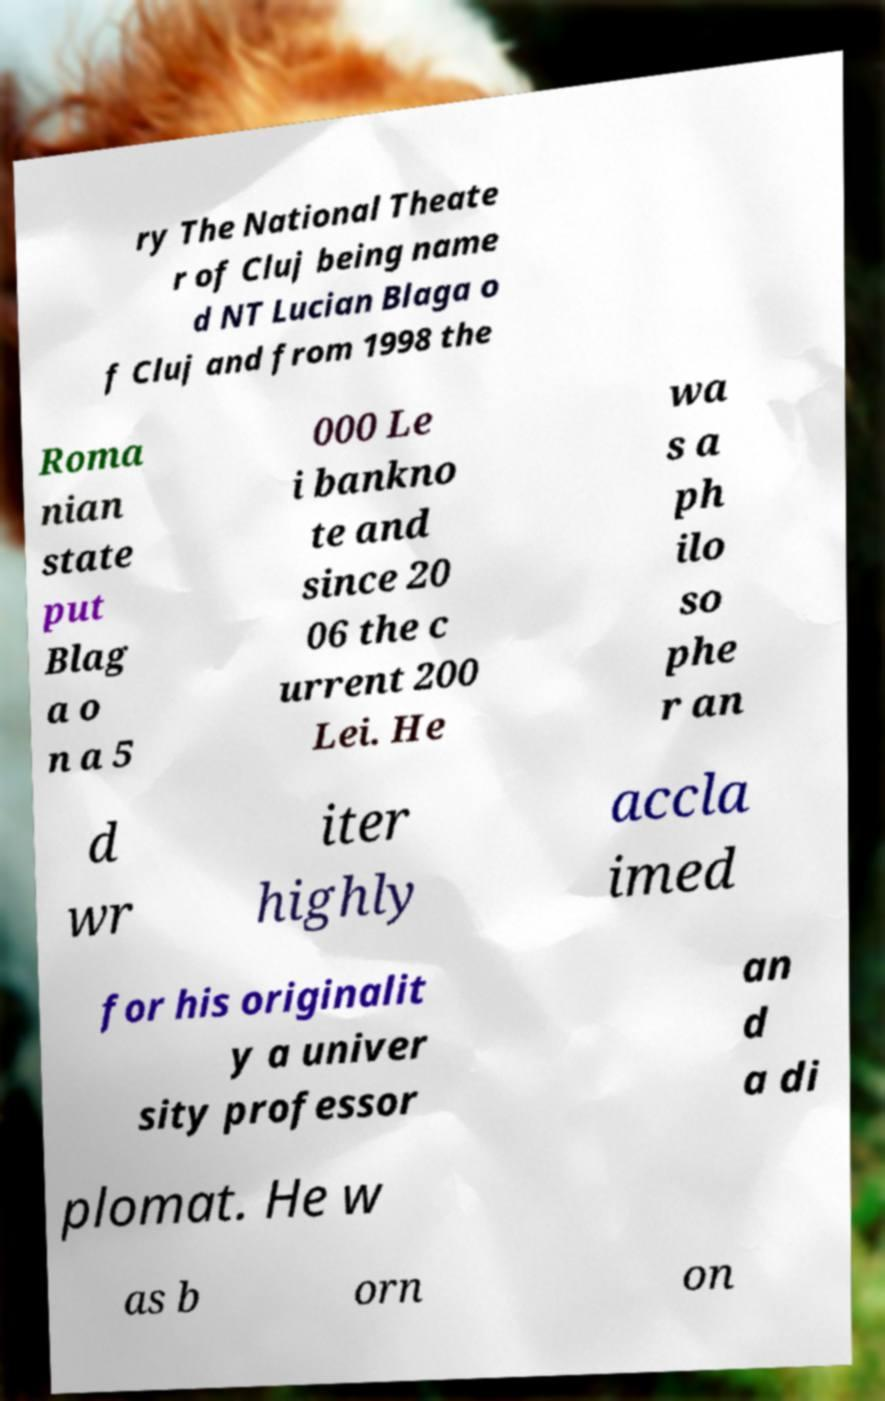For documentation purposes, I need the text within this image transcribed. Could you provide that? ry The National Theate r of Cluj being name d NT Lucian Blaga o f Cluj and from 1998 the Roma nian state put Blag a o n a 5 000 Le i bankno te and since 20 06 the c urrent 200 Lei. He wa s a ph ilo so phe r an d wr iter highly accla imed for his originalit y a univer sity professor an d a di plomat. He w as b orn on 